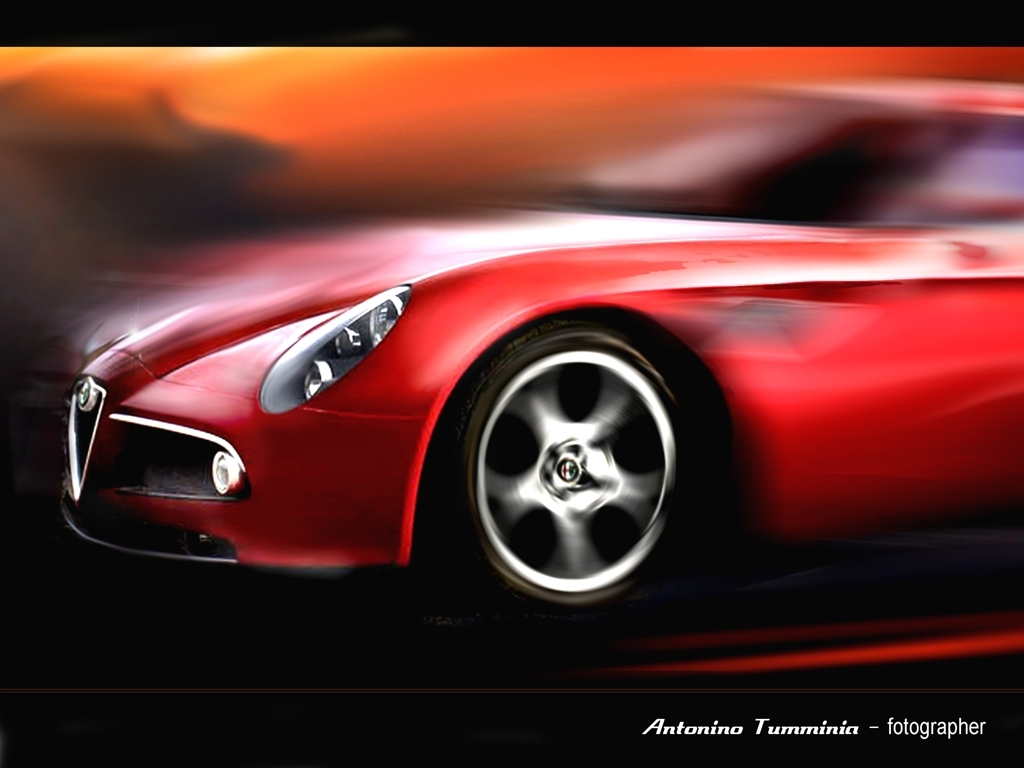Can you tell me more about the car featured in the photo? While specific details aren't clear due to the blur, the car seems to be a sports model, recognizable by its sleek design and prominent front grill. The focus on the vehicle suggests it might be used for marketing or artistic purposes rather than depicting an actual race. What does the color of the car signify? Red is often associated with excitement, speed, and dynamic energy, which harmonizes with the theme of motion in the photograph. It also is a popular color for sports cars, emphasizing their aggressive and high-performance nature. 